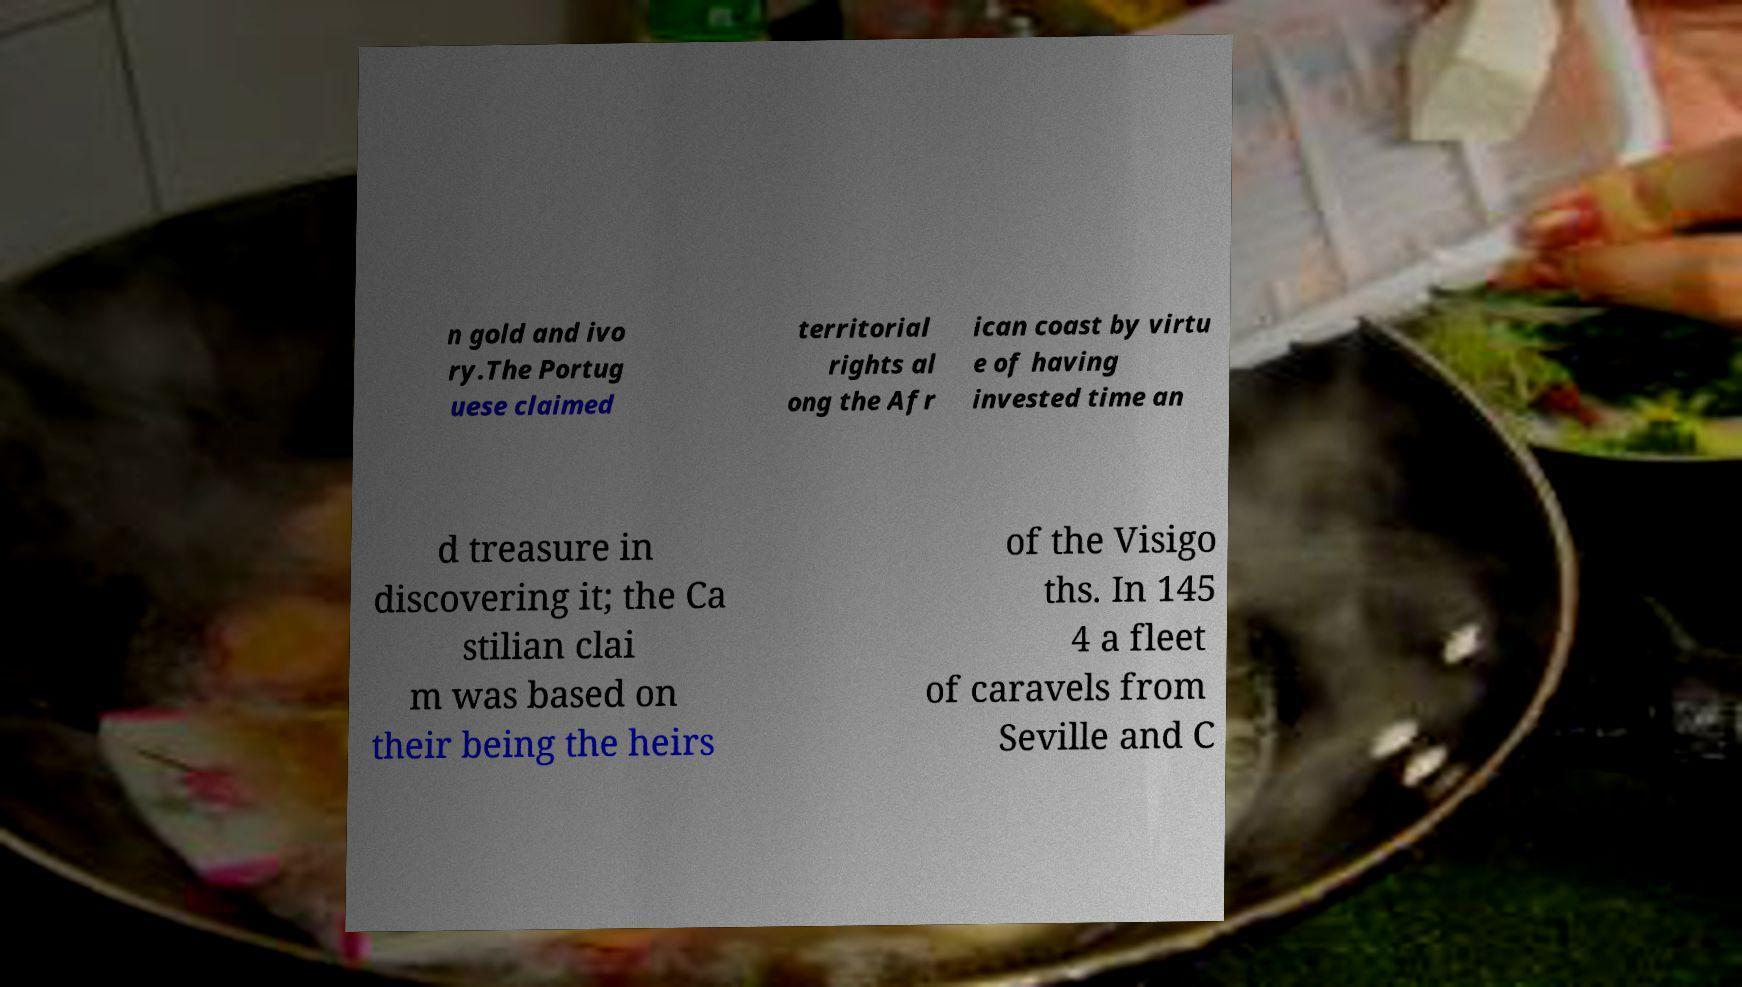Could you assist in decoding the text presented in this image and type it out clearly? n gold and ivo ry.The Portug uese claimed territorial rights al ong the Afr ican coast by virtu e of having invested time an d treasure in discovering it; the Ca stilian clai m was based on their being the heirs of the Visigo ths. In 145 4 a fleet of caravels from Seville and C 